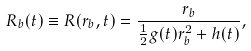<formula> <loc_0><loc_0><loc_500><loc_500>R _ { b } ( t ) \equiv R ( r _ { b } , t ) = \frac { r _ { b } } { \frac { 1 } { 2 } g ( t ) r _ { b } ^ { 2 } + h ( t ) } ,</formula> 